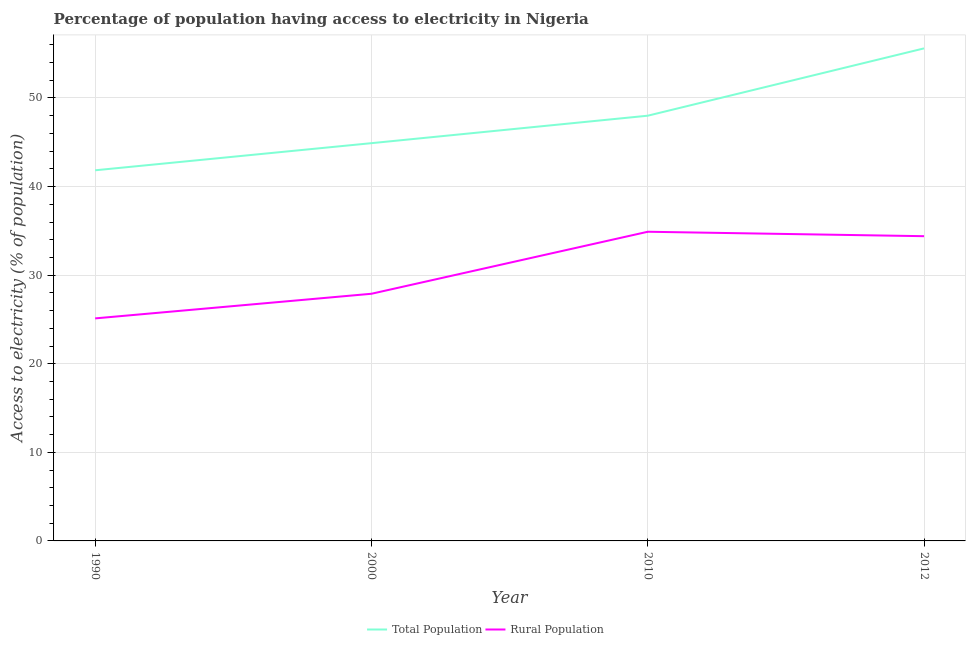How many different coloured lines are there?
Make the answer very short. 2. Is the number of lines equal to the number of legend labels?
Give a very brief answer. Yes. What is the percentage of population having access to electricity in 1990?
Offer a terse response. 41.84. Across all years, what is the maximum percentage of population having access to electricity?
Ensure brevity in your answer.  55.6. Across all years, what is the minimum percentage of rural population having access to electricity?
Your response must be concise. 25.12. In which year was the percentage of rural population having access to electricity maximum?
Your response must be concise. 2010. In which year was the percentage of population having access to electricity minimum?
Provide a succinct answer. 1990. What is the total percentage of rural population having access to electricity in the graph?
Ensure brevity in your answer.  122.32. What is the difference between the percentage of population having access to electricity in 2010 and that in 2012?
Offer a terse response. -7.6. What is the difference between the percentage of population having access to electricity in 2010 and the percentage of rural population having access to electricity in 2012?
Provide a short and direct response. 13.6. What is the average percentage of population having access to electricity per year?
Ensure brevity in your answer.  47.58. In the year 1990, what is the difference between the percentage of rural population having access to electricity and percentage of population having access to electricity?
Offer a very short reply. -16.72. What is the ratio of the percentage of rural population having access to electricity in 1990 to that in 2012?
Ensure brevity in your answer.  0.73. Is the difference between the percentage of population having access to electricity in 1990 and 2000 greater than the difference between the percentage of rural population having access to electricity in 1990 and 2000?
Make the answer very short. No. What is the difference between the highest and the second highest percentage of population having access to electricity?
Provide a short and direct response. 7.6. What is the difference between the highest and the lowest percentage of rural population having access to electricity?
Offer a terse response. 9.78. Does the percentage of population having access to electricity monotonically increase over the years?
Provide a short and direct response. Yes. Is the percentage of rural population having access to electricity strictly greater than the percentage of population having access to electricity over the years?
Ensure brevity in your answer.  No. Is the percentage of rural population having access to electricity strictly less than the percentage of population having access to electricity over the years?
Keep it short and to the point. Yes. How many lines are there?
Offer a very short reply. 2. How many years are there in the graph?
Your response must be concise. 4. Are the values on the major ticks of Y-axis written in scientific E-notation?
Make the answer very short. No. Does the graph contain any zero values?
Make the answer very short. No. Where does the legend appear in the graph?
Your response must be concise. Bottom center. What is the title of the graph?
Your answer should be very brief. Percentage of population having access to electricity in Nigeria. Does "Age 65(female)" appear as one of the legend labels in the graph?
Ensure brevity in your answer.  No. What is the label or title of the Y-axis?
Provide a succinct answer. Access to electricity (% of population). What is the Access to electricity (% of population) of Total Population in 1990?
Make the answer very short. 41.84. What is the Access to electricity (% of population) in Rural Population in 1990?
Your answer should be very brief. 25.12. What is the Access to electricity (% of population) in Total Population in 2000?
Keep it short and to the point. 44.9. What is the Access to electricity (% of population) of Rural Population in 2000?
Offer a terse response. 27.9. What is the Access to electricity (% of population) of Rural Population in 2010?
Provide a short and direct response. 34.9. What is the Access to electricity (% of population) of Total Population in 2012?
Offer a very short reply. 55.6. What is the Access to electricity (% of population) in Rural Population in 2012?
Give a very brief answer. 34.4. Across all years, what is the maximum Access to electricity (% of population) in Total Population?
Provide a short and direct response. 55.6. Across all years, what is the maximum Access to electricity (% of population) in Rural Population?
Offer a very short reply. 34.9. Across all years, what is the minimum Access to electricity (% of population) of Total Population?
Offer a terse response. 41.84. Across all years, what is the minimum Access to electricity (% of population) in Rural Population?
Offer a terse response. 25.12. What is the total Access to electricity (% of population) of Total Population in the graph?
Your response must be concise. 190.34. What is the total Access to electricity (% of population) in Rural Population in the graph?
Keep it short and to the point. 122.32. What is the difference between the Access to electricity (% of population) in Total Population in 1990 and that in 2000?
Offer a terse response. -3.06. What is the difference between the Access to electricity (% of population) of Rural Population in 1990 and that in 2000?
Your answer should be very brief. -2.78. What is the difference between the Access to electricity (% of population) of Total Population in 1990 and that in 2010?
Ensure brevity in your answer.  -6.16. What is the difference between the Access to electricity (% of population) of Rural Population in 1990 and that in 2010?
Provide a succinct answer. -9.78. What is the difference between the Access to electricity (% of population) of Total Population in 1990 and that in 2012?
Your answer should be very brief. -13.76. What is the difference between the Access to electricity (% of population) in Rural Population in 1990 and that in 2012?
Your answer should be very brief. -9.28. What is the difference between the Access to electricity (% of population) in Total Population in 2000 and that in 2010?
Provide a short and direct response. -3.1. What is the difference between the Access to electricity (% of population) of Rural Population in 2000 and that in 2010?
Provide a short and direct response. -7. What is the difference between the Access to electricity (% of population) of Rural Population in 2010 and that in 2012?
Provide a short and direct response. 0.5. What is the difference between the Access to electricity (% of population) of Total Population in 1990 and the Access to electricity (% of population) of Rural Population in 2000?
Offer a very short reply. 13.94. What is the difference between the Access to electricity (% of population) in Total Population in 1990 and the Access to electricity (% of population) in Rural Population in 2010?
Offer a very short reply. 6.94. What is the difference between the Access to electricity (% of population) of Total Population in 1990 and the Access to electricity (% of population) of Rural Population in 2012?
Your answer should be compact. 7.44. What is the difference between the Access to electricity (% of population) in Total Population in 2000 and the Access to electricity (% of population) in Rural Population in 2010?
Provide a succinct answer. 10. What is the difference between the Access to electricity (% of population) in Total Population in 2000 and the Access to electricity (% of population) in Rural Population in 2012?
Offer a terse response. 10.5. What is the difference between the Access to electricity (% of population) of Total Population in 2010 and the Access to electricity (% of population) of Rural Population in 2012?
Your answer should be compact. 13.6. What is the average Access to electricity (% of population) in Total Population per year?
Ensure brevity in your answer.  47.58. What is the average Access to electricity (% of population) in Rural Population per year?
Ensure brevity in your answer.  30.58. In the year 1990, what is the difference between the Access to electricity (% of population) in Total Population and Access to electricity (% of population) in Rural Population?
Give a very brief answer. 16.72. In the year 2012, what is the difference between the Access to electricity (% of population) in Total Population and Access to electricity (% of population) in Rural Population?
Your answer should be compact. 21.2. What is the ratio of the Access to electricity (% of population) of Total Population in 1990 to that in 2000?
Give a very brief answer. 0.93. What is the ratio of the Access to electricity (% of population) of Rural Population in 1990 to that in 2000?
Ensure brevity in your answer.  0.9. What is the ratio of the Access to electricity (% of population) of Total Population in 1990 to that in 2010?
Your answer should be very brief. 0.87. What is the ratio of the Access to electricity (% of population) in Rural Population in 1990 to that in 2010?
Offer a terse response. 0.72. What is the ratio of the Access to electricity (% of population) of Total Population in 1990 to that in 2012?
Your answer should be very brief. 0.75. What is the ratio of the Access to electricity (% of population) of Rural Population in 1990 to that in 2012?
Your answer should be very brief. 0.73. What is the ratio of the Access to electricity (% of population) in Total Population in 2000 to that in 2010?
Offer a terse response. 0.94. What is the ratio of the Access to electricity (% of population) in Rural Population in 2000 to that in 2010?
Ensure brevity in your answer.  0.8. What is the ratio of the Access to electricity (% of population) of Total Population in 2000 to that in 2012?
Offer a terse response. 0.81. What is the ratio of the Access to electricity (% of population) in Rural Population in 2000 to that in 2012?
Make the answer very short. 0.81. What is the ratio of the Access to electricity (% of population) of Total Population in 2010 to that in 2012?
Your answer should be very brief. 0.86. What is the ratio of the Access to electricity (% of population) in Rural Population in 2010 to that in 2012?
Your response must be concise. 1.01. What is the difference between the highest and the lowest Access to electricity (% of population) in Total Population?
Make the answer very short. 13.76. What is the difference between the highest and the lowest Access to electricity (% of population) of Rural Population?
Ensure brevity in your answer.  9.78. 